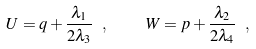<formula> <loc_0><loc_0><loc_500><loc_500>U = q + \frac { \lambda _ { 1 } } { 2 \lambda _ { 3 } } \ , \quad W = p + \frac { \lambda _ { 2 } } { 2 \lambda _ { 4 } } \ ,</formula> 